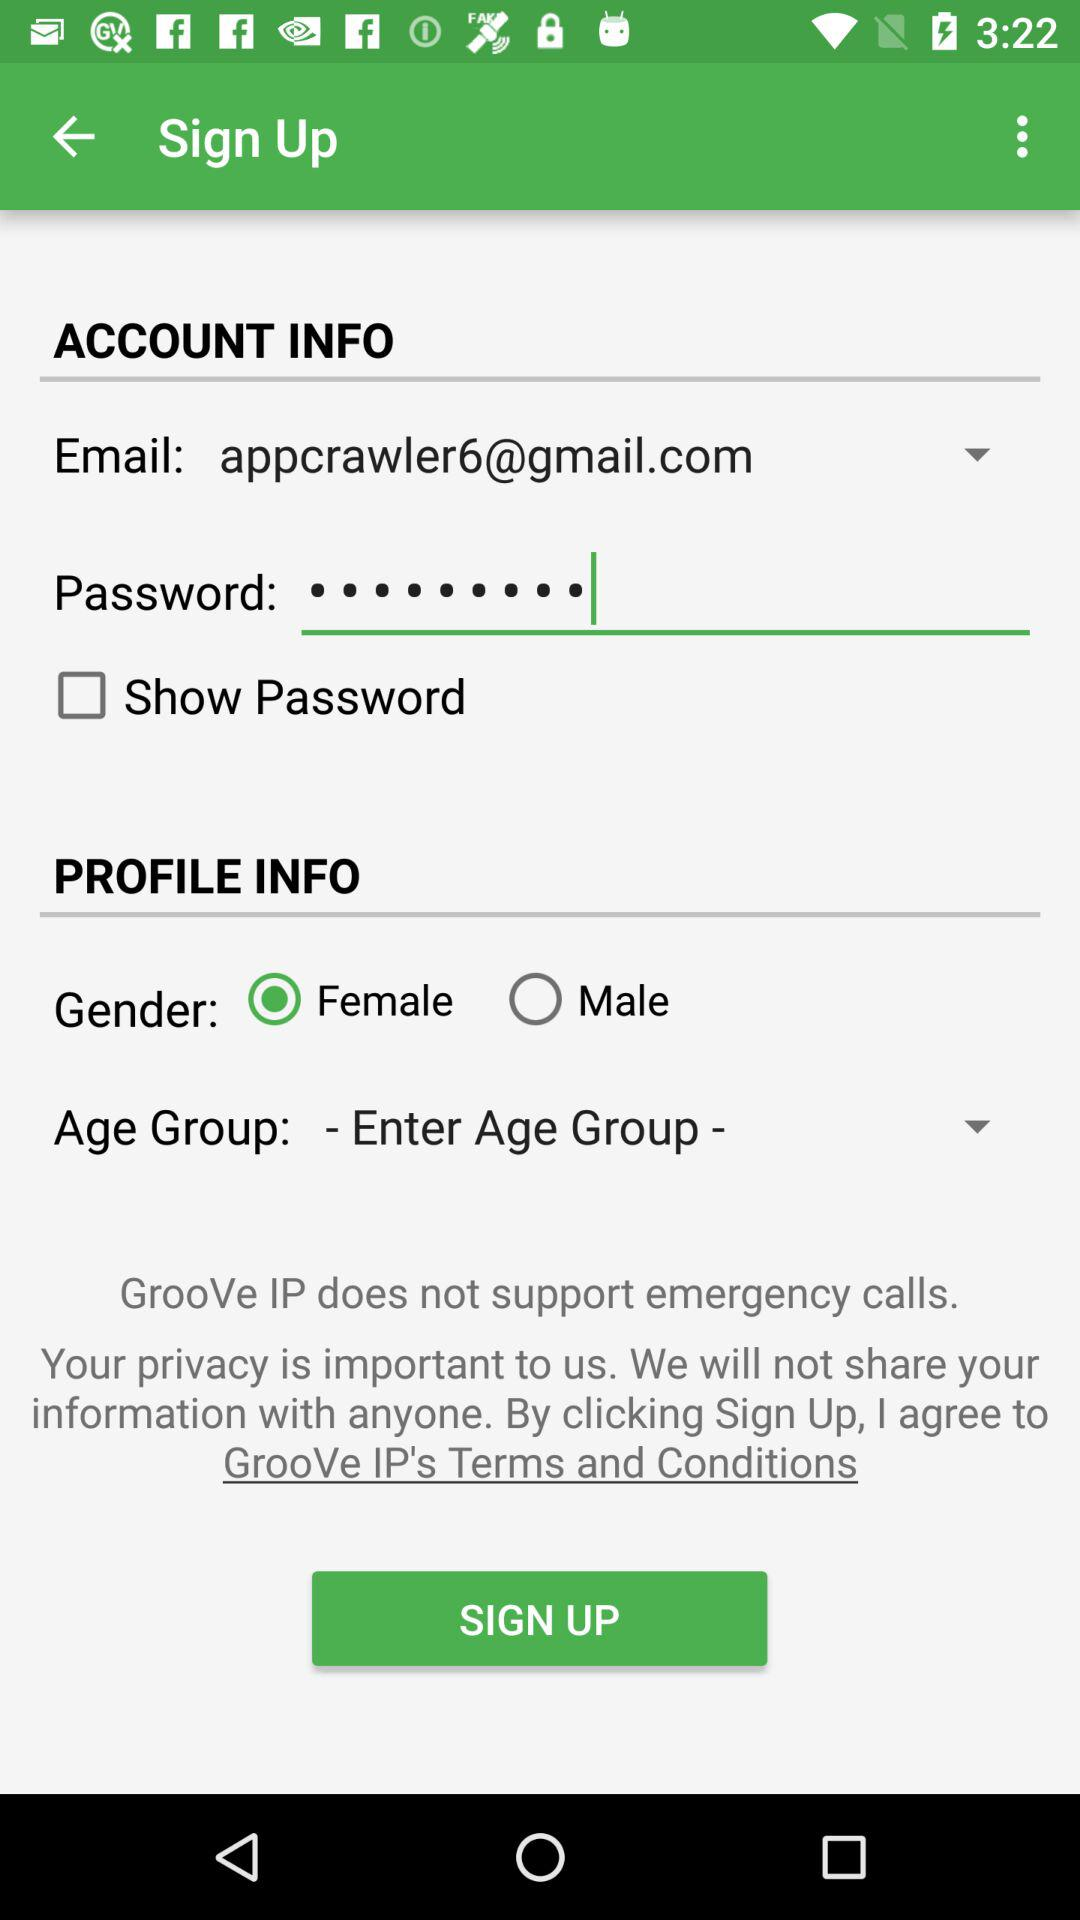What is the email? The email is appcrawler6@gmail.com. 